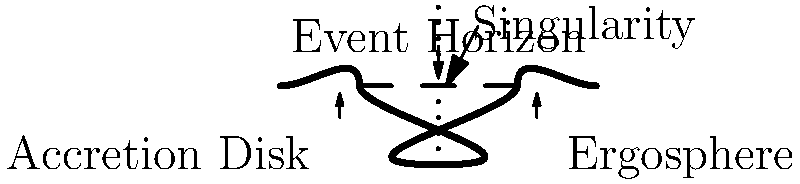In the cross-sectional diagram of a black hole, which component represents the boundary beyond which nothing can escape the gravitational pull, and how does it relate to the concept of escape velocity? To answer this question, let's break down the key components of a black hole and their significance:

1. Event Horizon: This is the boundary beyond which nothing, not even light, can escape the black hole's gravitational pull. It's represented by the dashed line in the diagram.

2. Singularity: The central point of infinite density and zero volume, where the laws of physics break down. It's shown as a dotted vertical line in the diagram.

3. Accretion Disk: The disk of matter spiraling into the black hole, visible in the lower left part of the diagram.

4. Ergosphere: The region just outside the event horizon where space-time is dragged along with the black hole's rotation, shown in the lower right part of the diagram.

The event horizon is the key to answering this question. It relates to the concept of escape velocity in the following way:

- Escape velocity is the minimum speed an object needs to escape a gravitational field without further propulsion.
- As you get closer to a massive object, the escape velocity increases.
- At the event horizon of a black hole, the escape velocity becomes equal to the speed of light (c).
- Since nothing can travel faster than light according to Einstein's theory of relativity, nothing can escape once it crosses the event horizon.

The equation for escape velocity is:

$$ v_e = \sqrt{\frac{2GM}{r}} $$

Where:
$v_e$ is the escape velocity
$G$ is the gravitational constant
$M$ is the mass of the object (in this case, the black hole)
$r$ is the distance from the center of the object

As $r$ approaches the event horizon radius (Schwarzschild radius for a non-rotating black hole), $v_e$ approaches $c$.
Answer: Event Horizon; escape velocity equals speed of light 